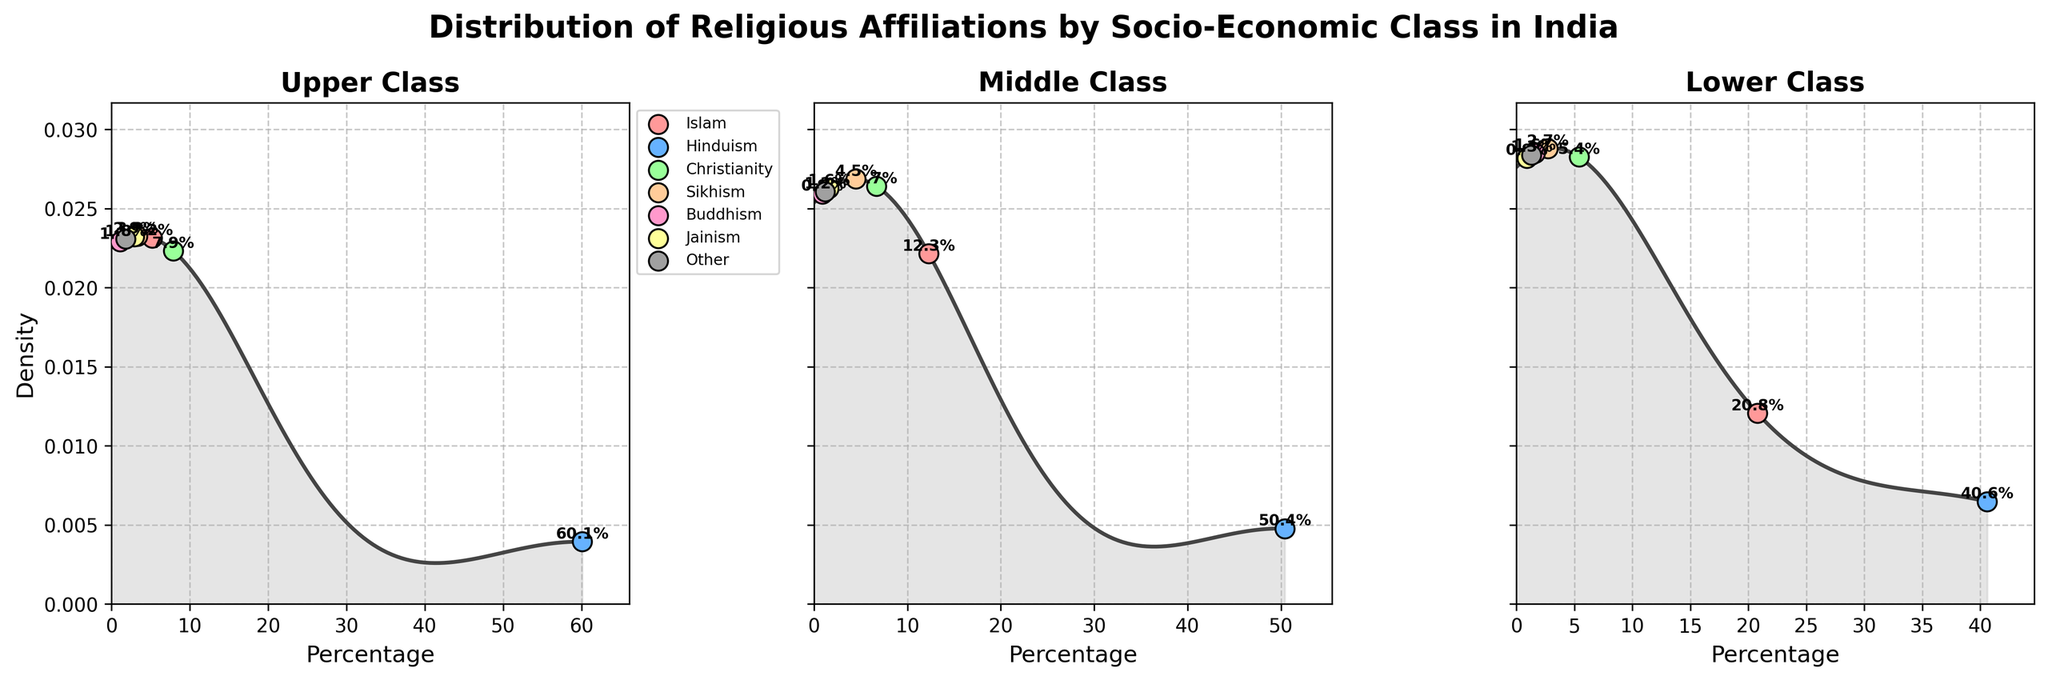What is the title of the plot? The title is given at the top of the plot. Titles usually indicate the main subject of the plot.
Answer: Distribution of Religious Affiliations by Socio-Economic Class in India Which socio-economic class has the highest percentage of Hindus? From the figure, observe the peaks and placements of the scatter points along the percentage axis. The "Upper" class shows the highest scatter point for Hinduism at 60.1%.
Answer: Upper What is the percentage of Muslims in the Lower socio-economic class? Look at the scatter point labeled "Islam" within the "Lower" class subplot. The label next to it reads 20.8%.
Answer: 20.8% Which socio-economic class has the most diverse religious affiliations based on the number of different religions displayed? Compare the number of scatter points in each subplot representing different religions. "Upper" and "Middle" classes display more scatter points (7 religions each) compared to "Lower" class (7 religions). Thus, all classes are equally diverse based on number.
Answer: Upper, Middle, and Lower all display 7 religions Which socio-economic class has the lowest density peak? Compare the height of the density curves in all three subplots. The "Middle" class has the densest curve that's comparatively lower.
Answer: Middle What is the combined percentage of Christians in all socio-economic classes? Sum up the percentages of Christians from all three subplots: Upper (7.9%), Middle (6.7%), and Lower (5.4%). The combined value is 7.9% + 6.7% + 5.4% = 20%.
Answer: 20% Which two religions have the closest percentage values in the "Upper" class? Observe the scatter points in the "Upper" class subplot. Christianity (7.9%) and Islam (5.2%) have the closest values.
Answer: Christianity and Islam Does the percentage of Buddhists increase or decrease from Upper to Lower socio-economic class? Track the scatter points labeled "Buddhism" across the three subplots. Upper (1.1%), Middle (0.9%), Lower (1.6%). It first decreases from Upper to Middle, then increases to Lower.
Answer: Increases overall Which religious group has the highest combined percentage across all socio-economic classes? Compare the combined percentages of each religion across all classes. Hinduism has the combined highest: Upper (60.1%), Middle (50.4%), Lower (40.6%) adding up to 151.1.
Answer: Hinduism 